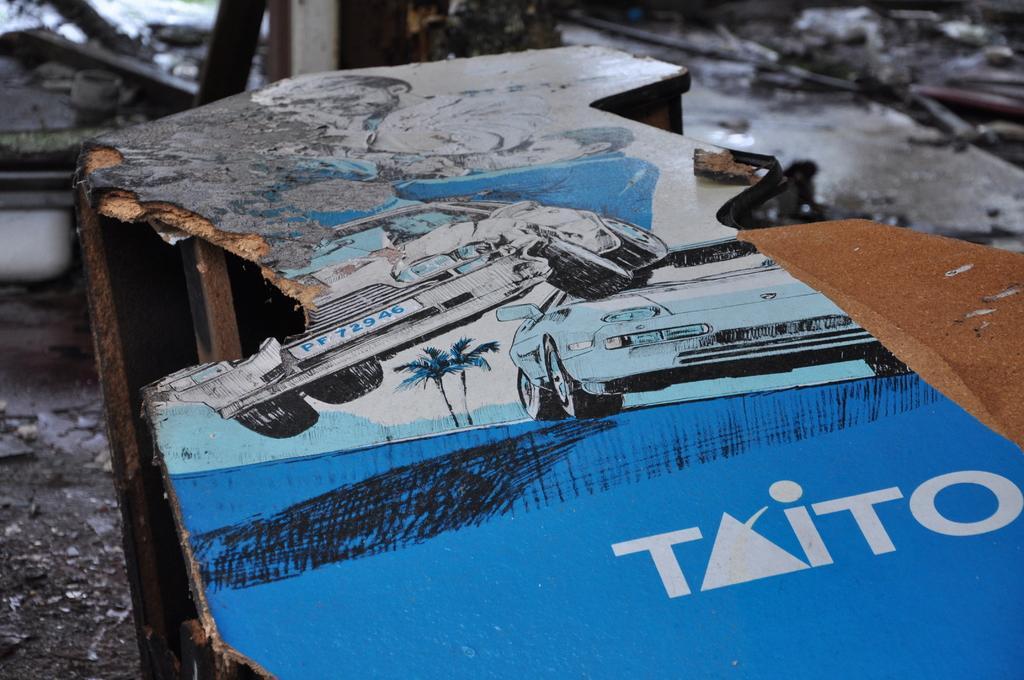Could you give a brief overview of what you see in this image? In this image we can see a wooden piece with poster of car and some text on it in the foreground. And there is a floor at the bottom. 